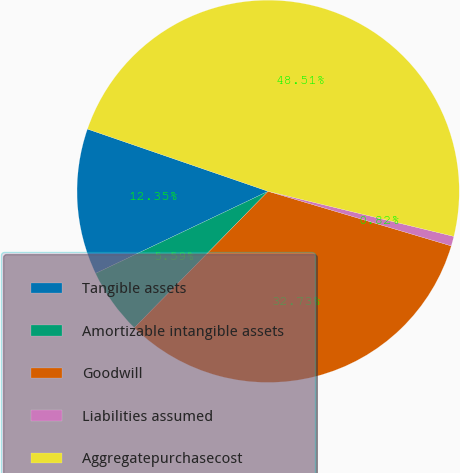<chart> <loc_0><loc_0><loc_500><loc_500><pie_chart><fcel>Tangible assets<fcel>Amortizable intangible assets<fcel>Goodwill<fcel>Liabilities assumed<fcel>Aggregatepurchasecost<nl><fcel>12.35%<fcel>5.59%<fcel>32.73%<fcel>0.82%<fcel>48.51%<nl></chart> 